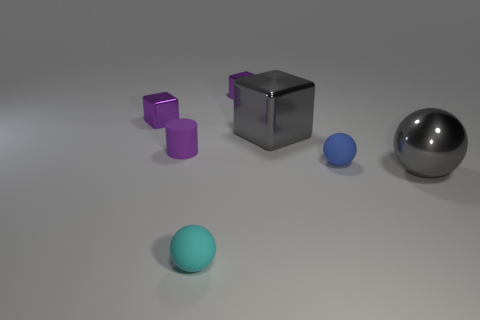Subtract all big blocks. How many blocks are left? 2 Add 1 small brown shiny spheres. How many objects exist? 8 Subtract 3 spheres. How many spheres are left? 0 Subtract all gray spheres. How many spheres are left? 2 Subtract all red spheres. How many purple blocks are left? 2 Subtract all cylinders. How many objects are left? 6 Add 2 tiny blue objects. How many tiny blue objects exist? 3 Subtract 1 cyan spheres. How many objects are left? 6 Subtract all yellow cylinders. Subtract all brown blocks. How many cylinders are left? 1 Subtract all tiny cyan cubes. Subtract all matte cylinders. How many objects are left? 6 